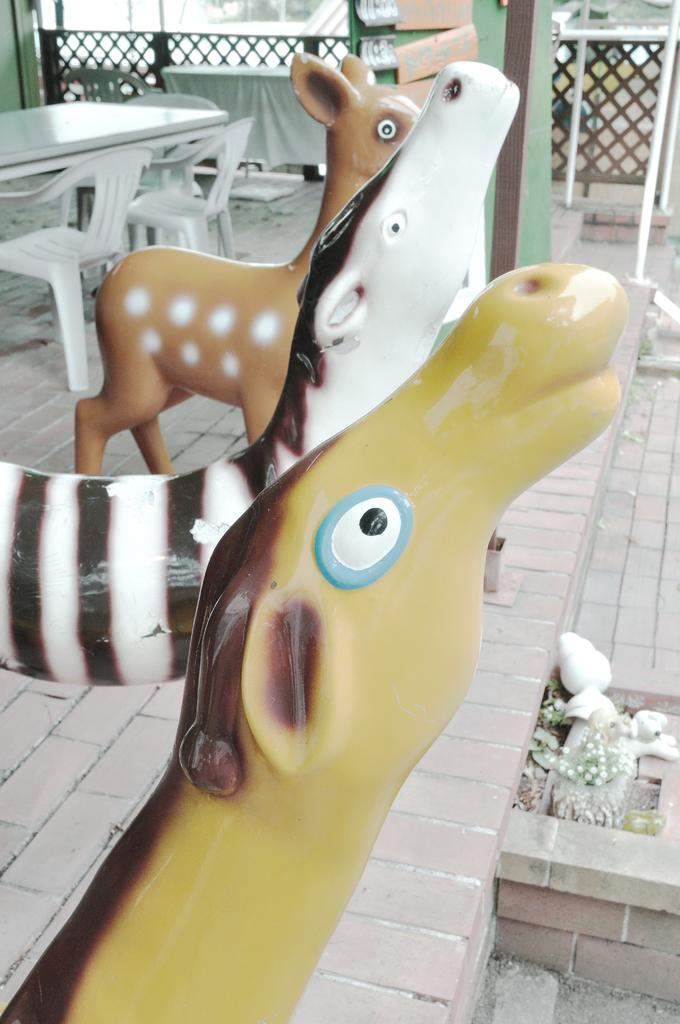What objects are on the path in the image? There are toys on the path in the image. What type of furniture is present in the image? There is a table in the image. How many chairs are visible on the left side of the image? There are two chairs on the left side of the image. What type of fencing can be seen in the image? There is wooden fencing visible from left to right in the image. Can you see a giraffe walking downtown in the image? There is no giraffe or downtown area present in the image. What direction is the table pointing in the image? The image does not provide information about the direction the table is pointing. 